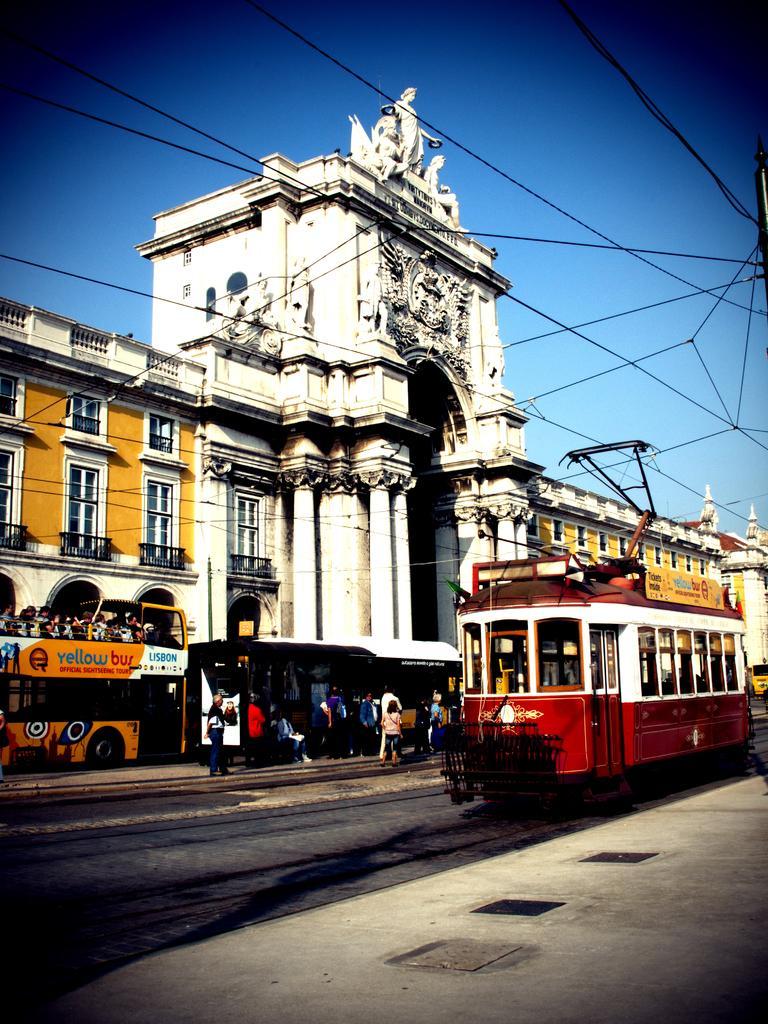Please provide a concise description of this image. In this image there is a train at right side of this image and there are some persons are standing as we can see in middle of this image and there is a building in the background and there is a blue sky at top of this image and there is a railway track at bottom left side of this image and there are some current wires as we can see at middle of this image. 